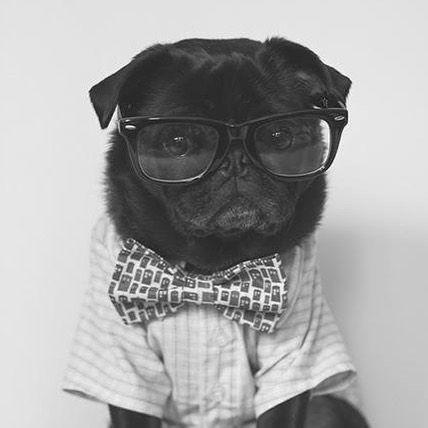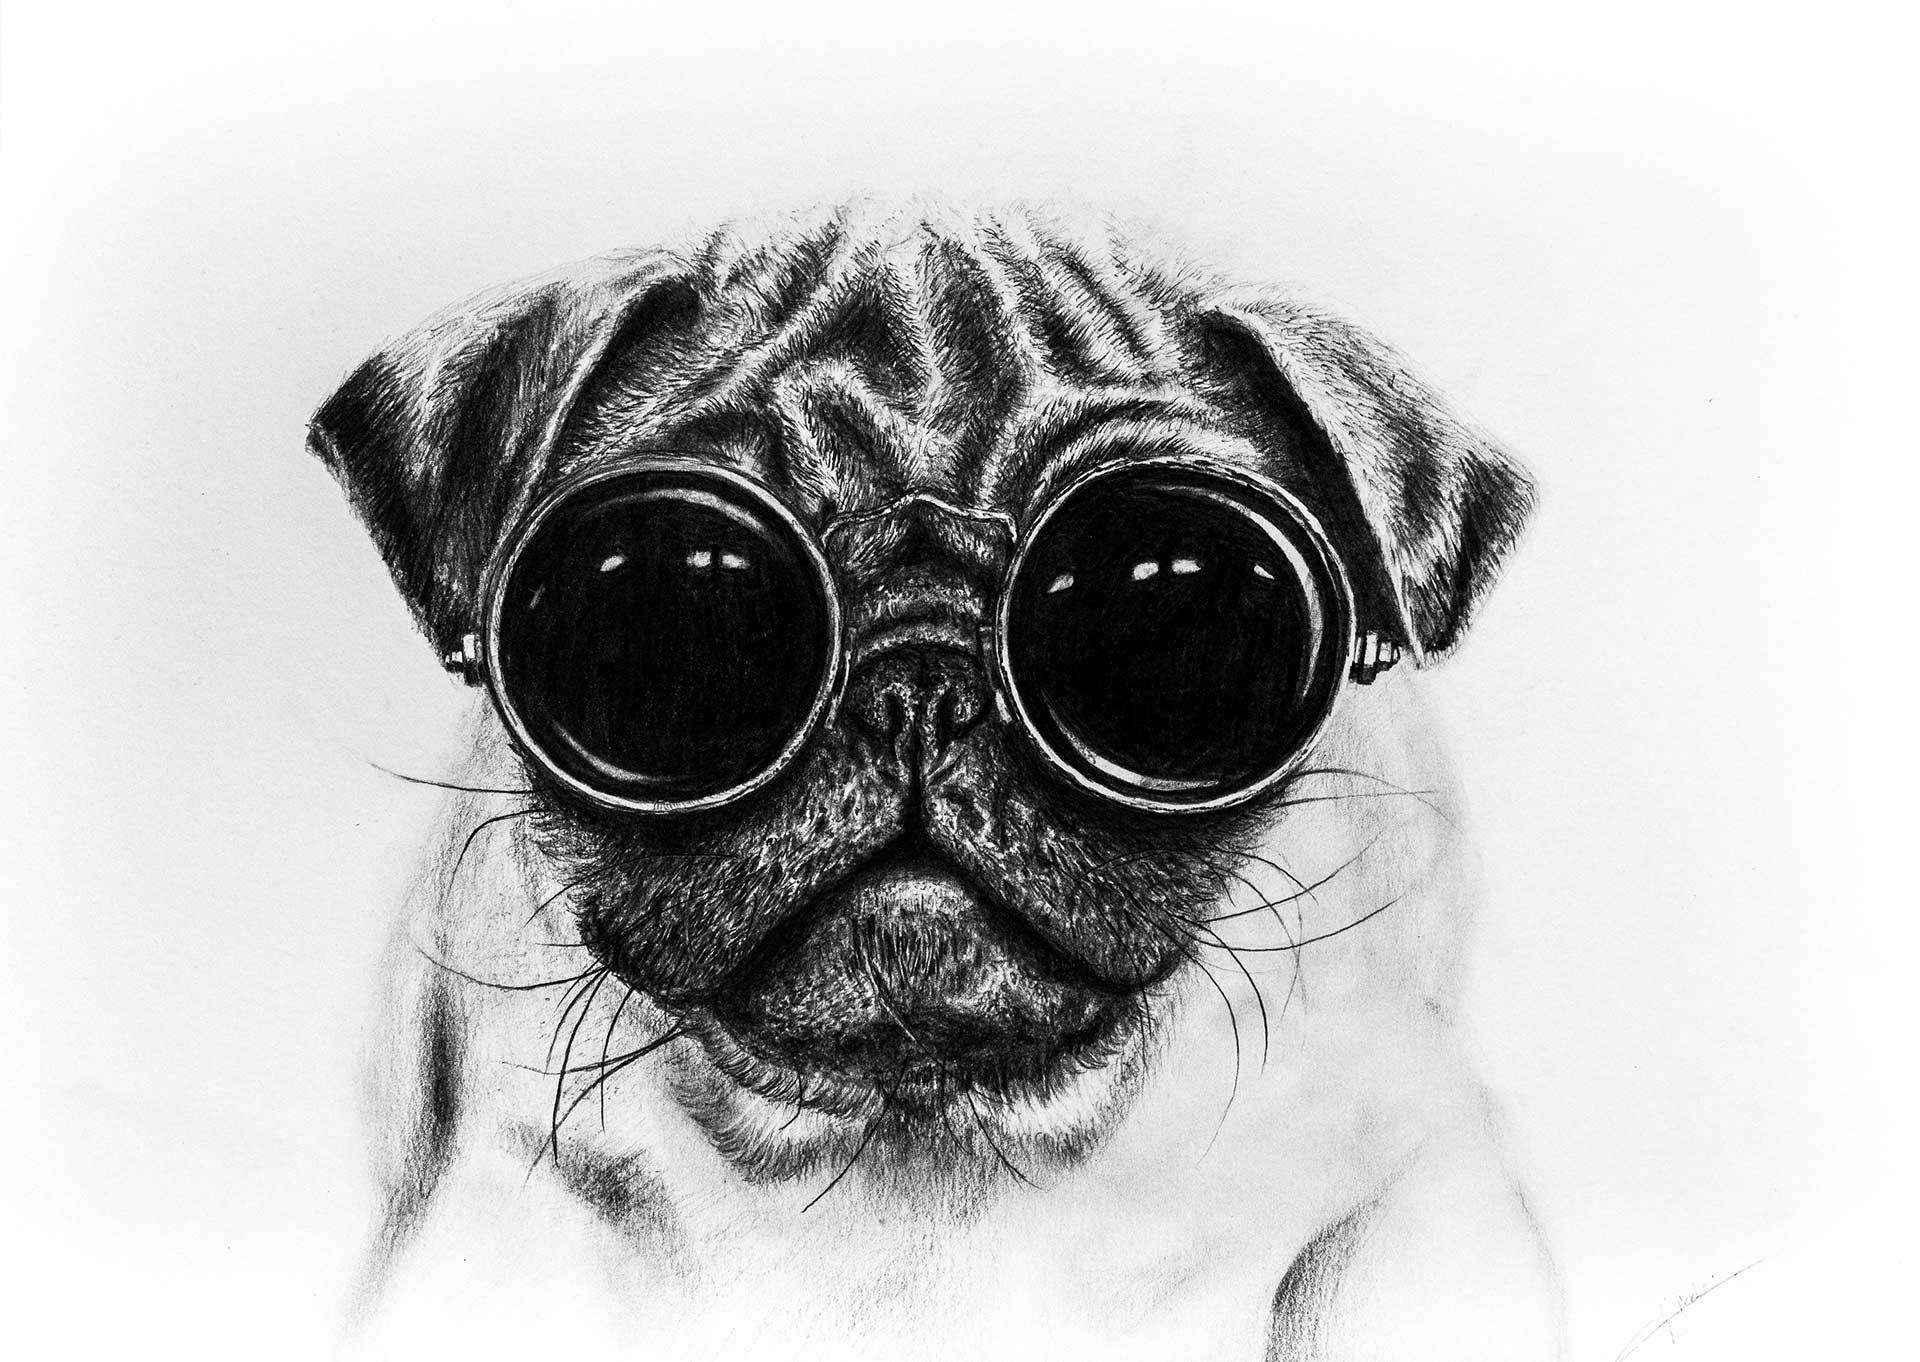The first image is the image on the left, the second image is the image on the right. For the images shown, is this caption "The pug in the right image faces the camera head-on and wears glasses with round lenses." true? Answer yes or no. Yes. The first image is the image on the left, the second image is the image on the right. For the images displayed, is the sentence "The pug on the right is wearing glasses with round frames." factually correct? Answer yes or no. Yes. 